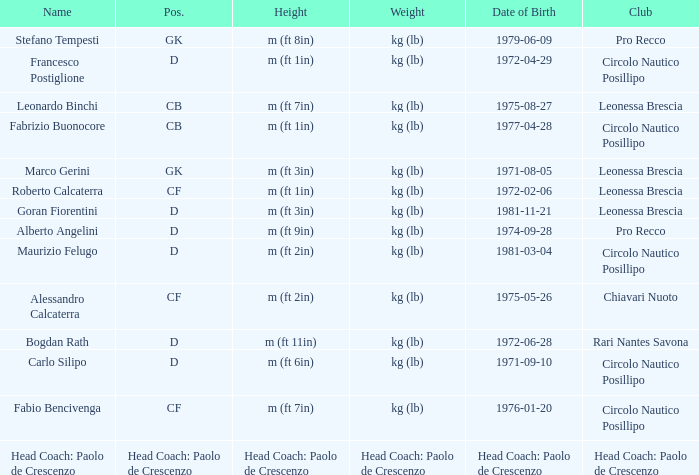What is the position of the player with a height of m (ft 6in)? D. 